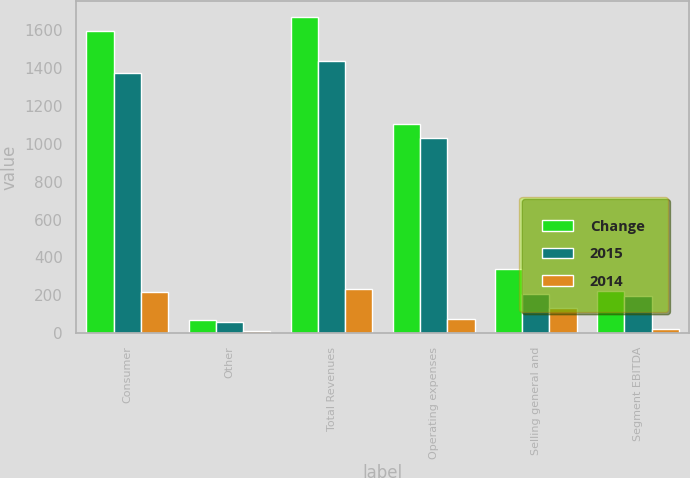Convert chart to OTSL. <chart><loc_0><loc_0><loc_500><loc_500><stacked_bar_chart><ecel><fcel>Consumer<fcel>Other<fcel>Total Revenues<fcel>Operating expenses<fcel>Selling general and<fcel>Segment EBITDA<nl><fcel>Change<fcel>1594<fcel>73<fcel>1667<fcel>1106<fcel>340<fcel>221<nl><fcel>2015<fcel>1374<fcel>60<fcel>1434<fcel>1029<fcel>208<fcel>197<nl><fcel>2014<fcel>220<fcel>13<fcel>233<fcel>77<fcel>132<fcel>24<nl></chart> 